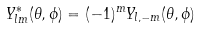<formula> <loc_0><loc_0><loc_500><loc_500>Y _ { l m } ^ { \ast } ( \theta , \phi ) = ( - 1 ) ^ { m } Y _ { l , - m } ( \theta , \phi )</formula> 